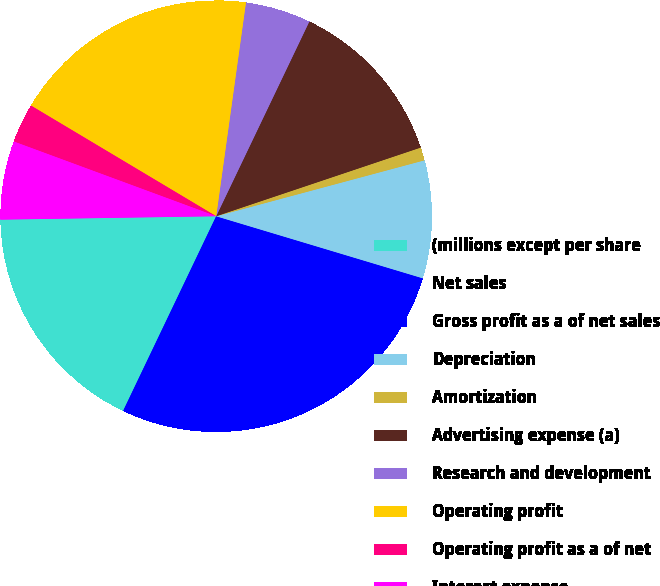Convert chart to OTSL. <chart><loc_0><loc_0><loc_500><loc_500><pie_chart><fcel>(millions except per share<fcel>Net sales<fcel>Gross profit as a of net sales<fcel>Depreciation<fcel>Amortization<fcel>Advertising expense (a)<fcel>Research and development<fcel>Operating profit<fcel>Operating profit as a of net<fcel>Interest expense<nl><fcel>17.65%<fcel>23.53%<fcel>3.92%<fcel>8.82%<fcel>0.98%<fcel>12.74%<fcel>4.9%<fcel>18.63%<fcel>2.94%<fcel>5.88%<nl></chart> 